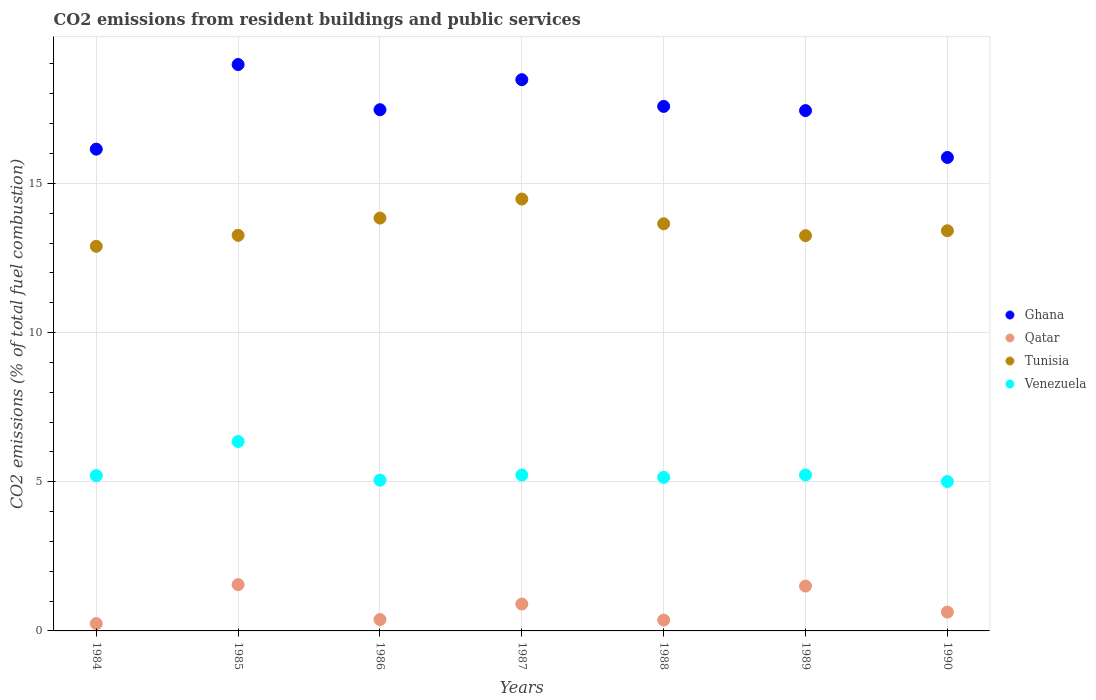How many different coloured dotlines are there?
Your response must be concise. 4. What is the total CO2 emitted in Tunisia in 1987?
Give a very brief answer. 14.47. Across all years, what is the maximum total CO2 emitted in Tunisia?
Your answer should be compact. 14.47. Across all years, what is the minimum total CO2 emitted in Ghana?
Your answer should be compact. 15.87. What is the total total CO2 emitted in Venezuela in the graph?
Your response must be concise. 37.21. What is the difference between the total CO2 emitted in Ghana in 1987 and that in 1989?
Give a very brief answer. 1.04. What is the difference between the total CO2 emitted in Qatar in 1985 and the total CO2 emitted in Venezuela in 1988?
Make the answer very short. -3.6. What is the average total CO2 emitted in Tunisia per year?
Offer a terse response. 13.54. In the year 1987, what is the difference between the total CO2 emitted in Qatar and total CO2 emitted in Tunisia?
Provide a succinct answer. -13.57. In how many years, is the total CO2 emitted in Qatar greater than 5?
Give a very brief answer. 0. What is the ratio of the total CO2 emitted in Venezuela in 1985 to that in 1990?
Offer a terse response. 1.27. Is the total CO2 emitted in Venezuela in 1984 less than that in 1990?
Offer a terse response. No. What is the difference between the highest and the second highest total CO2 emitted in Tunisia?
Your response must be concise. 0.64. What is the difference between the highest and the lowest total CO2 emitted in Ghana?
Provide a succinct answer. 3.11. Is the sum of the total CO2 emitted in Tunisia in 1988 and 1989 greater than the maximum total CO2 emitted in Venezuela across all years?
Your answer should be compact. Yes. Is it the case that in every year, the sum of the total CO2 emitted in Qatar and total CO2 emitted in Venezuela  is greater than the sum of total CO2 emitted in Tunisia and total CO2 emitted in Ghana?
Make the answer very short. No. Is it the case that in every year, the sum of the total CO2 emitted in Ghana and total CO2 emitted in Qatar  is greater than the total CO2 emitted in Venezuela?
Your response must be concise. Yes. Does the total CO2 emitted in Tunisia monotonically increase over the years?
Your answer should be compact. No. Is the total CO2 emitted in Tunisia strictly less than the total CO2 emitted in Venezuela over the years?
Ensure brevity in your answer.  No. Are the values on the major ticks of Y-axis written in scientific E-notation?
Your answer should be compact. No. Where does the legend appear in the graph?
Keep it short and to the point. Center right. How are the legend labels stacked?
Ensure brevity in your answer.  Vertical. What is the title of the graph?
Make the answer very short. CO2 emissions from resident buildings and public services. What is the label or title of the Y-axis?
Offer a terse response. CO2 emissions (% of total fuel combustion). What is the CO2 emissions (% of total fuel combustion) in Ghana in 1984?
Provide a succinct answer. 16.15. What is the CO2 emissions (% of total fuel combustion) of Qatar in 1984?
Give a very brief answer. 0.25. What is the CO2 emissions (% of total fuel combustion) of Tunisia in 1984?
Keep it short and to the point. 12.89. What is the CO2 emissions (% of total fuel combustion) in Venezuela in 1984?
Offer a terse response. 5.21. What is the CO2 emissions (% of total fuel combustion) of Ghana in 1985?
Your answer should be compact. 18.98. What is the CO2 emissions (% of total fuel combustion) in Qatar in 1985?
Your response must be concise. 1.55. What is the CO2 emissions (% of total fuel combustion) in Tunisia in 1985?
Offer a terse response. 13.26. What is the CO2 emissions (% of total fuel combustion) of Venezuela in 1985?
Offer a very short reply. 6.35. What is the CO2 emissions (% of total fuel combustion) of Ghana in 1986?
Your answer should be very brief. 17.47. What is the CO2 emissions (% of total fuel combustion) in Qatar in 1986?
Offer a very short reply. 0.38. What is the CO2 emissions (% of total fuel combustion) of Tunisia in 1986?
Provide a short and direct response. 13.84. What is the CO2 emissions (% of total fuel combustion) in Venezuela in 1986?
Offer a terse response. 5.05. What is the CO2 emissions (% of total fuel combustion) in Ghana in 1987?
Ensure brevity in your answer.  18.47. What is the CO2 emissions (% of total fuel combustion) in Qatar in 1987?
Make the answer very short. 0.9. What is the CO2 emissions (% of total fuel combustion) of Tunisia in 1987?
Your response must be concise. 14.47. What is the CO2 emissions (% of total fuel combustion) in Venezuela in 1987?
Offer a very short reply. 5.22. What is the CO2 emissions (% of total fuel combustion) of Ghana in 1988?
Offer a very short reply. 17.58. What is the CO2 emissions (% of total fuel combustion) in Qatar in 1988?
Provide a short and direct response. 0.36. What is the CO2 emissions (% of total fuel combustion) of Tunisia in 1988?
Ensure brevity in your answer.  13.64. What is the CO2 emissions (% of total fuel combustion) in Venezuela in 1988?
Make the answer very short. 5.15. What is the CO2 emissions (% of total fuel combustion) of Ghana in 1989?
Your response must be concise. 17.44. What is the CO2 emissions (% of total fuel combustion) of Qatar in 1989?
Your response must be concise. 1.5. What is the CO2 emissions (% of total fuel combustion) of Tunisia in 1989?
Offer a terse response. 13.25. What is the CO2 emissions (% of total fuel combustion) of Venezuela in 1989?
Ensure brevity in your answer.  5.23. What is the CO2 emissions (% of total fuel combustion) of Ghana in 1990?
Provide a short and direct response. 15.87. What is the CO2 emissions (% of total fuel combustion) of Qatar in 1990?
Give a very brief answer. 0.63. What is the CO2 emissions (% of total fuel combustion) of Tunisia in 1990?
Your answer should be compact. 13.41. What is the CO2 emissions (% of total fuel combustion) in Venezuela in 1990?
Ensure brevity in your answer.  5.01. Across all years, what is the maximum CO2 emissions (% of total fuel combustion) of Ghana?
Make the answer very short. 18.98. Across all years, what is the maximum CO2 emissions (% of total fuel combustion) in Qatar?
Offer a terse response. 1.55. Across all years, what is the maximum CO2 emissions (% of total fuel combustion) in Tunisia?
Give a very brief answer. 14.47. Across all years, what is the maximum CO2 emissions (% of total fuel combustion) in Venezuela?
Offer a very short reply. 6.35. Across all years, what is the minimum CO2 emissions (% of total fuel combustion) of Ghana?
Ensure brevity in your answer.  15.87. Across all years, what is the minimum CO2 emissions (% of total fuel combustion) of Qatar?
Give a very brief answer. 0.25. Across all years, what is the minimum CO2 emissions (% of total fuel combustion) of Tunisia?
Offer a very short reply. 12.89. Across all years, what is the minimum CO2 emissions (% of total fuel combustion) in Venezuela?
Give a very brief answer. 5.01. What is the total CO2 emissions (% of total fuel combustion) of Ghana in the graph?
Keep it short and to the point. 121.95. What is the total CO2 emissions (% of total fuel combustion) in Qatar in the graph?
Your answer should be very brief. 5.57. What is the total CO2 emissions (% of total fuel combustion) of Tunisia in the graph?
Keep it short and to the point. 94.76. What is the total CO2 emissions (% of total fuel combustion) of Venezuela in the graph?
Your answer should be compact. 37.21. What is the difference between the CO2 emissions (% of total fuel combustion) of Ghana in 1984 and that in 1985?
Offer a terse response. -2.84. What is the difference between the CO2 emissions (% of total fuel combustion) in Qatar in 1984 and that in 1985?
Keep it short and to the point. -1.3. What is the difference between the CO2 emissions (% of total fuel combustion) of Tunisia in 1984 and that in 1985?
Offer a very short reply. -0.37. What is the difference between the CO2 emissions (% of total fuel combustion) in Venezuela in 1984 and that in 1985?
Provide a succinct answer. -1.14. What is the difference between the CO2 emissions (% of total fuel combustion) in Ghana in 1984 and that in 1986?
Ensure brevity in your answer.  -1.32. What is the difference between the CO2 emissions (% of total fuel combustion) in Qatar in 1984 and that in 1986?
Provide a succinct answer. -0.13. What is the difference between the CO2 emissions (% of total fuel combustion) in Tunisia in 1984 and that in 1986?
Provide a short and direct response. -0.95. What is the difference between the CO2 emissions (% of total fuel combustion) in Venezuela in 1984 and that in 1986?
Provide a short and direct response. 0.15. What is the difference between the CO2 emissions (% of total fuel combustion) in Ghana in 1984 and that in 1987?
Keep it short and to the point. -2.33. What is the difference between the CO2 emissions (% of total fuel combustion) of Qatar in 1984 and that in 1987?
Your response must be concise. -0.65. What is the difference between the CO2 emissions (% of total fuel combustion) of Tunisia in 1984 and that in 1987?
Your response must be concise. -1.58. What is the difference between the CO2 emissions (% of total fuel combustion) in Venezuela in 1984 and that in 1987?
Give a very brief answer. -0.02. What is the difference between the CO2 emissions (% of total fuel combustion) of Ghana in 1984 and that in 1988?
Offer a terse response. -1.43. What is the difference between the CO2 emissions (% of total fuel combustion) in Qatar in 1984 and that in 1988?
Make the answer very short. -0.12. What is the difference between the CO2 emissions (% of total fuel combustion) in Tunisia in 1984 and that in 1988?
Offer a very short reply. -0.76. What is the difference between the CO2 emissions (% of total fuel combustion) in Venezuela in 1984 and that in 1988?
Provide a short and direct response. 0.06. What is the difference between the CO2 emissions (% of total fuel combustion) of Ghana in 1984 and that in 1989?
Ensure brevity in your answer.  -1.29. What is the difference between the CO2 emissions (% of total fuel combustion) in Qatar in 1984 and that in 1989?
Your answer should be compact. -1.26. What is the difference between the CO2 emissions (% of total fuel combustion) of Tunisia in 1984 and that in 1989?
Keep it short and to the point. -0.36. What is the difference between the CO2 emissions (% of total fuel combustion) of Venezuela in 1984 and that in 1989?
Your response must be concise. -0.02. What is the difference between the CO2 emissions (% of total fuel combustion) in Ghana in 1984 and that in 1990?
Ensure brevity in your answer.  0.28. What is the difference between the CO2 emissions (% of total fuel combustion) in Qatar in 1984 and that in 1990?
Your answer should be very brief. -0.38. What is the difference between the CO2 emissions (% of total fuel combustion) of Tunisia in 1984 and that in 1990?
Your answer should be very brief. -0.52. What is the difference between the CO2 emissions (% of total fuel combustion) of Venezuela in 1984 and that in 1990?
Your answer should be compact. 0.2. What is the difference between the CO2 emissions (% of total fuel combustion) of Ghana in 1985 and that in 1986?
Ensure brevity in your answer.  1.51. What is the difference between the CO2 emissions (% of total fuel combustion) of Qatar in 1985 and that in 1986?
Provide a succinct answer. 1.17. What is the difference between the CO2 emissions (% of total fuel combustion) of Tunisia in 1985 and that in 1986?
Give a very brief answer. -0.58. What is the difference between the CO2 emissions (% of total fuel combustion) of Venezuela in 1985 and that in 1986?
Give a very brief answer. 1.3. What is the difference between the CO2 emissions (% of total fuel combustion) of Ghana in 1985 and that in 1987?
Your response must be concise. 0.51. What is the difference between the CO2 emissions (% of total fuel combustion) of Qatar in 1985 and that in 1987?
Keep it short and to the point. 0.65. What is the difference between the CO2 emissions (% of total fuel combustion) of Tunisia in 1985 and that in 1987?
Give a very brief answer. -1.22. What is the difference between the CO2 emissions (% of total fuel combustion) in Venezuela in 1985 and that in 1987?
Give a very brief answer. 1.12. What is the difference between the CO2 emissions (% of total fuel combustion) of Ghana in 1985 and that in 1988?
Ensure brevity in your answer.  1.4. What is the difference between the CO2 emissions (% of total fuel combustion) of Qatar in 1985 and that in 1988?
Provide a short and direct response. 1.19. What is the difference between the CO2 emissions (% of total fuel combustion) of Tunisia in 1985 and that in 1988?
Your response must be concise. -0.39. What is the difference between the CO2 emissions (% of total fuel combustion) in Venezuela in 1985 and that in 1988?
Provide a succinct answer. 1.2. What is the difference between the CO2 emissions (% of total fuel combustion) of Ghana in 1985 and that in 1989?
Your answer should be compact. 1.54. What is the difference between the CO2 emissions (% of total fuel combustion) of Qatar in 1985 and that in 1989?
Offer a terse response. 0.05. What is the difference between the CO2 emissions (% of total fuel combustion) of Tunisia in 1985 and that in 1989?
Offer a very short reply. 0.01. What is the difference between the CO2 emissions (% of total fuel combustion) in Venezuela in 1985 and that in 1989?
Your answer should be compact. 1.12. What is the difference between the CO2 emissions (% of total fuel combustion) in Ghana in 1985 and that in 1990?
Ensure brevity in your answer.  3.11. What is the difference between the CO2 emissions (% of total fuel combustion) in Qatar in 1985 and that in 1990?
Provide a succinct answer. 0.92. What is the difference between the CO2 emissions (% of total fuel combustion) of Tunisia in 1985 and that in 1990?
Offer a terse response. -0.15. What is the difference between the CO2 emissions (% of total fuel combustion) of Venezuela in 1985 and that in 1990?
Provide a succinct answer. 1.34. What is the difference between the CO2 emissions (% of total fuel combustion) in Ghana in 1986 and that in 1987?
Keep it short and to the point. -1.01. What is the difference between the CO2 emissions (% of total fuel combustion) of Qatar in 1986 and that in 1987?
Your response must be concise. -0.52. What is the difference between the CO2 emissions (% of total fuel combustion) of Tunisia in 1986 and that in 1987?
Provide a succinct answer. -0.64. What is the difference between the CO2 emissions (% of total fuel combustion) in Venezuela in 1986 and that in 1987?
Provide a succinct answer. -0.17. What is the difference between the CO2 emissions (% of total fuel combustion) of Ghana in 1986 and that in 1988?
Your response must be concise. -0.11. What is the difference between the CO2 emissions (% of total fuel combustion) in Qatar in 1986 and that in 1988?
Ensure brevity in your answer.  0.02. What is the difference between the CO2 emissions (% of total fuel combustion) in Tunisia in 1986 and that in 1988?
Offer a terse response. 0.19. What is the difference between the CO2 emissions (% of total fuel combustion) in Venezuela in 1986 and that in 1988?
Your answer should be compact. -0.1. What is the difference between the CO2 emissions (% of total fuel combustion) in Ghana in 1986 and that in 1989?
Offer a very short reply. 0.03. What is the difference between the CO2 emissions (% of total fuel combustion) in Qatar in 1986 and that in 1989?
Keep it short and to the point. -1.12. What is the difference between the CO2 emissions (% of total fuel combustion) in Tunisia in 1986 and that in 1989?
Your answer should be compact. 0.59. What is the difference between the CO2 emissions (% of total fuel combustion) of Venezuela in 1986 and that in 1989?
Provide a succinct answer. -0.18. What is the difference between the CO2 emissions (% of total fuel combustion) in Ghana in 1986 and that in 1990?
Offer a terse response. 1.6. What is the difference between the CO2 emissions (% of total fuel combustion) in Qatar in 1986 and that in 1990?
Your response must be concise. -0.25. What is the difference between the CO2 emissions (% of total fuel combustion) in Tunisia in 1986 and that in 1990?
Provide a succinct answer. 0.42. What is the difference between the CO2 emissions (% of total fuel combustion) of Venezuela in 1986 and that in 1990?
Make the answer very short. 0.05. What is the difference between the CO2 emissions (% of total fuel combustion) of Ghana in 1987 and that in 1988?
Give a very brief answer. 0.9. What is the difference between the CO2 emissions (% of total fuel combustion) in Qatar in 1987 and that in 1988?
Provide a short and direct response. 0.54. What is the difference between the CO2 emissions (% of total fuel combustion) in Tunisia in 1987 and that in 1988?
Provide a short and direct response. 0.83. What is the difference between the CO2 emissions (% of total fuel combustion) of Venezuela in 1987 and that in 1988?
Keep it short and to the point. 0.08. What is the difference between the CO2 emissions (% of total fuel combustion) in Ghana in 1987 and that in 1989?
Ensure brevity in your answer.  1.04. What is the difference between the CO2 emissions (% of total fuel combustion) of Qatar in 1987 and that in 1989?
Your response must be concise. -0.6. What is the difference between the CO2 emissions (% of total fuel combustion) of Tunisia in 1987 and that in 1989?
Your answer should be very brief. 1.23. What is the difference between the CO2 emissions (% of total fuel combustion) of Venezuela in 1987 and that in 1989?
Provide a succinct answer. -0. What is the difference between the CO2 emissions (% of total fuel combustion) of Ghana in 1987 and that in 1990?
Your answer should be very brief. 2.61. What is the difference between the CO2 emissions (% of total fuel combustion) of Qatar in 1987 and that in 1990?
Provide a short and direct response. 0.27. What is the difference between the CO2 emissions (% of total fuel combustion) in Tunisia in 1987 and that in 1990?
Offer a very short reply. 1.06. What is the difference between the CO2 emissions (% of total fuel combustion) in Venezuela in 1987 and that in 1990?
Your answer should be very brief. 0.22. What is the difference between the CO2 emissions (% of total fuel combustion) of Ghana in 1988 and that in 1989?
Give a very brief answer. 0.14. What is the difference between the CO2 emissions (% of total fuel combustion) of Qatar in 1988 and that in 1989?
Your response must be concise. -1.14. What is the difference between the CO2 emissions (% of total fuel combustion) of Tunisia in 1988 and that in 1989?
Offer a very short reply. 0.4. What is the difference between the CO2 emissions (% of total fuel combustion) of Venezuela in 1988 and that in 1989?
Provide a succinct answer. -0.08. What is the difference between the CO2 emissions (% of total fuel combustion) of Ghana in 1988 and that in 1990?
Provide a short and direct response. 1.71. What is the difference between the CO2 emissions (% of total fuel combustion) in Qatar in 1988 and that in 1990?
Your answer should be compact. -0.27. What is the difference between the CO2 emissions (% of total fuel combustion) of Tunisia in 1988 and that in 1990?
Your answer should be compact. 0.23. What is the difference between the CO2 emissions (% of total fuel combustion) of Venezuela in 1988 and that in 1990?
Offer a terse response. 0.14. What is the difference between the CO2 emissions (% of total fuel combustion) of Ghana in 1989 and that in 1990?
Ensure brevity in your answer.  1.57. What is the difference between the CO2 emissions (% of total fuel combustion) in Qatar in 1989 and that in 1990?
Your response must be concise. 0.87. What is the difference between the CO2 emissions (% of total fuel combustion) in Tunisia in 1989 and that in 1990?
Offer a terse response. -0.16. What is the difference between the CO2 emissions (% of total fuel combustion) of Venezuela in 1989 and that in 1990?
Offer a terse response. 0.22. What is the difference between the CO2 emissions (% of total fuel combustion) in Ghana in 1984 and the CO2 emissions (% of total fuel combustion) in Qatar in 1985?
Ensure brevity in your answer.  14.59. What is the difference between the CO2 emissions (% of total fuel combustion) of Ghana in 1984 and the CO2 emissions (% of total fuel combustion) of Tunisia in 1985?
Your answer should be compact. 2.89. What is the difference between the CO2 emissions (% of total fuel combustion) of Ghana in 1984 and the CO2 emissions (% of total fuel combustion) of Venezuela in 1985?
Keep it short and to the point. 9.8. What is the difference between the CO2 emissions (% of total fuel combustion) of Qatar in 1984 and the CO2 emissions (% of total fuel combustion) of Tunisia in 1985?
Provide a short and direct response. -13.01. What is the difference between the CO2 emissions (% of total fuel combustion) of Qatar in 1984 and the CO2 emissions (% of total fuel combustion) of Venezuela in 1985?
Ensure brevity in your answer.  -6.1. What is the difference between the CO2 emissions (% of total fuel combustion) of Tunisia in 1984 and the CO2 emissions (% of total fuel combustion) of Venezuela in 1985?
Offer a terse response. 6.54. What is the difference between the CO2 emissions (% of total fuel combustion) of Ghana in 1984 and the CO2 emissions (% of total fuel combustion) of Qatar in 1986?
Offer a terse response. 15.77. What is the difference between the CO2 emissions (% of total fuel combustion) in Ghana in 1984 and the CO2 emissions (% of total fuel combustion) in Tunisia in 1986?
Your answer should be compact. 2.31. What is the difference between the CO2 emissions (% of total fuel combustion) of Ghana in 1984 and the CO2 emissions (% of total fuel combustion) of Venezuela in 1986?
Your response must be concise. 11.09. What is the difference between the CO2 emissions (% of total fuel combustion) of Qatar in 1984 and the CO2 emissions (% of total fuel combustion) of Tunisia in 1986?
Offer a terse response. -13.59. What is the difference between the CO2 emissions (% of total fuel combustion) of Qatar in 1984 and the CO2 emissions (% of total fuel combustion) of Venezuela in 1986?
Your response must be concise. -4.8. What is the difference between the CO2 emissions (% of total fuel combustion) of Tunisia in 1984 and the CO2 emissions (% of total fuel combustion) of Venezuela in 1986?
Offer a very short reply. 7.84. What is the difference between the CO2 emissions (% of total fuel combustion) in Ghana in 1984 and the CO2 emissions (% of total fuel combustion) in Qatar in 1987?
Your answer should be compact. 15.25. What is the difference between the CO2 emissions (% of total fuel combustion) of Ghana in 1984 and the CO2 emissions (% of total fuel combustion) of Tunisia in 1987?
Keep it short and to the point. 1.67. What is the difference between the CO2 emissions (% of total fuel combustion) in Ghana in 1984 and the CO2 emissions (% of total fuel combustion) in Venezuela in 1987?
Provide a short and direct response. 10.92. What is the difference between the CO2 emissions (% of total fuel combustion) in Qatar in 1984 and the CO2 emissions (% of total fuel combustion) in Tunisia in 1987?
Provide a succinct answer. -14.23. What is the difference between the CO2 emissions (% of total fuel combustion) in Qatar in 1984 and the CO2 emissions (% of total fuel combustion) in Venezuela in 1987?
Provide a succinct answer. -4.98. What is the difference between the CO2 emissions (% of total fuel combustion) of Tunisia in 1984 and the CO2 emissions (% of total fuel combustion) of Venezuela in 1987?
Ensure brevity in your answer.  7.67. What is the difference between the CO2 emissions (% of total fuel combustion) of Ghana in 1984 and the CO2 emissions (% of total fuel combustion) of Qatar in 1988?
Make the answer very short. 15.78. What is the difference between the CO2 emissions (% of total fuel combustion) in Ghana in 1984 and the CO2 emissions (% of total fuel combustion) in Tunisia in 1988?
Your answer should be very brief. 2.5. What is the difference between the CO2 emissions (% of total fuel combustion) of Ghana in 1984 and the CO2 emissions (% of total fuel combustion) of Venezuela in 1988?
Give a very brief answer. 11. What is the difference between the CO2 emissions (% of total fuel combustion) in Qatar in 1984 and the CO2 emissions (% of total fuel combustion) in Tunisia in 1988?
Your answer should be very brief. -13.4. What is the difference between the CO2 emissions (% of total fuel combustion) of Qatar in 1984 and the CO2 emissions (% of total fuel combustion) of Venezuela in 1988?
Your response must be concise. -4.9. What is the difference between the CO2 emissions (% of total fuel combustion) in Tunisia in 1984 and the CO2 emissions (% of total fuel combustion) in Venezuela in 1988?
Keep it short and to the point. 7.74. What is the difference between the CO2 emissions (% of total fuel combustion) of Ghana in 1984 and the CO2 emissions (% of total fuel combustion) of Qatar in 1989?
Offer a very short reply. 14.64. What is the difference between the CO2 emissions (% of total fuel combustion) of Ghana in 1984 and the CO2 emissions (% of total fuel combustion) of Tunisia in 1989?
Provide a short and direct response. 2.9. What is the difference between the CO2 emissions (% of total fuel combustion) of Ghana in 1984 and the CO2 emissions (% of total fuel combustion) of Venezuela in 1989?
Offer a very short reply. 10.92. What is the difference between the CO2 emissions (% of total fuel combustion) in Qatar in 1984 and the CO2 emissions (% of total fuel combustion) in Tunisia in 1989?
Offer a terse response. -13. What is the difference between the CO2 emissions (% of total fuel combustion) in Qatar in 1984 and the CO2 emissions (% of total fuel combustion) in Venezuela in 1989?
Provide a succinct answer. -4.98. What is the difference between the CO2 emissions (% of total fuel combustion) in Tunisia in 1984 and the CO2 emissions (% of total fuel combustion) in Venezuela in 1989?
Provide a succinct answer. 7.66. What is the difference between the CO2 emissions (% of total fuel combustion) in Ghana in 1984 and the CO2 emissions (% of total fuel combustion) in Qatar in 1990?
Your response must be concise. 15.52. What is the difference between the CO2 emissions (% of total fuel combustion) of Ghana in 1984 and the CO2 emissions (% of total fuel combustion) of Tunisia in 1990?
Your response must be concise. 2.74. What is the difference between the CO2 emissions (% of total fuel combustion) in Ghana in 1984 and the CO2 emissions (% of total fuel combustion) in Venezuela in 1990?
Keep it short and to the point. 11.14. What is the difference between the CO2 emissions (% of total fuel combustion) of Qatar in 1984 and the CO2 emissions (% of total fuel combustion) of Tunisia in 1990?
Ensure brevity in your answer.  -13.16. What is the difference between the CO2 emissions (% of total fuel combustion) of Qatar in 1984 and the CO2 emissions (% of total fuel combustion) of Venezuela in 1990?
Your response must be concise. -4.76. What is the difference between the CO2 emissions (% of total fuel combustion) in Tunisia in 1984 and the CO2 emissions (% of total fuel combustion) in Venezuela in 1990?
Keep it short and to the point. 7.88. What is the difference between the CO2 emissions (% of total fuel combustion) of Ghana in 1985 and the CO2 emissions (% of total fuel combustion) of Qatar in 1986?
Provide a succinct answer. 18.6. What is the difference between the CO2 emissions (% of total fuel combustion) in Ghana in 1985 and the CO2 emissions (% of total fuel combustion) in Tunisia in 1986?
Keep it short and to the point. 5.15. What is the difference between the CO2 emissions (% of total fuel combustion) of Ghana in 1985 and the CO2 emissions (% of total fuel combustion) of Venezuela in 1986?
Your answer should be very brief. 13.93. What is the difference between the CO2 emissions (% of total fuel combustion) in Qatar in 1985 and the CO2 emissions (% of total fuel combustion) in Tunisia in 1986?
Make the answer very short. -12.28. What is the difference between the CO2 emissions (% of total fuel combustion) of Qatar in 1985 and the CO2 emissions (% of total fuel combustion) of Venezuela in 1986?
Ensure brevity in your answer.  -3.5. What is the difference between the CO2 emissions (% of total fuel combustion) of Tunisia in 1985 and the CO2 emissions (% of total fuel combustion) of Venezuela in 1986?
Your answer should be very brief. 8.21. What is the difference between the CO2 emissions (% of total fuel combustion) in Ghana in 1985 and the CO2 emissions (% of total fuel combustion) in Qatar in 1987?
Provide a succinct answer. 18.08. What is the difference between the CO2 emissions (% of total fuel combustion) of Ghana in 1985 and the CO2 emissions (% of total fuel combustion) of Tunisia in 1987?
Your answer should be very brief. 4.51. What is the difference between the CO2 emissions (% of total fuel combustion) of Ghana in 1985 and the CO2 emissions (% of total fuel combustion) of Venezuela in 1987?
Make the answer very short. 13.76. What is the difference between the CO2 emissions (% of total fuel combustion) of Qatar in 1985 and the CO2 emissions (% of total fuel combustion) of Tunisia in 1987?
Your answer should be very brief. -12.92. What is the difference between the CO2 emissions (% of total fuel combustion) in Qatar in 1985 and the CO2 emissions (% of total fuel combustion) in Venezuela in 1987?
Offer a terse response. -3.67. What is the difference between the CO2 emissions (% of total fuel combustion) of Tunisia in 1985 and the CO2 emissions (% of total fuel combustion) of Venezuela in 1987?
Offer a terse response. 8.03. What is the difference between the CO2 emissions (% of total fuel combustion) in Ghana in 1985 and the CO2 emissions (% of total fuel combustion) in Qatar in 1988?
Make the answer very short. 18.62. What is the difference between the CO2 emissions (% of total fuel combustion) in Ghana in 1985 and the CO2 emissions (% of total fuel combustion) in Tunisia in 1988?
Ensure brevity in your answer.  5.34. What is the difference between the CO2 emissions (% of total fuel combustion) in Ghana in 1985 and the CO2 emissions (% of total fuel combustion) in Venezuela in 1988?
Your response must be concise. 13.83. What is the difference between the CO2 emissions (% of total fuel combustion) in Qatar in 1985 and the CO2 emissions (% of total fuel combustion) in Tunisia in 1988?
Give a very brief answer. -12.09. What is the difference between the CO2 emissions (% of total fuel combustion) in Qatar in 1985 and the CO2 emissions (% of total fuel combustion) in Venezuela in 1988?
Provide a succinct answer. -3.6. What is the difference between the CO2 emissions (% of total fuel combustion) of Tunisia in 1985 and the CO2 emissions (% of total fuel combustion) of Venezuela in 1988?
Your response must be concise. 8.11. What is the difference between the CO2 emissions (% of total fuel combustion) of Ghana in 1985 and the CO2 emissions (% of total fuel combustion) of Qatar in 1989?
Offer a terse response. 17.48. What is the difference between the CO2 emissions (% of total fuel combustion) of Ghana in 1985 and the CO2 emissions (% of total fuel combustion) of Tunisia in 1989?
Your response must be concise. 5.73. What is the difference between the CO2 emissions (% of total fuel combustion) in Ghana in 1985 and the CO2 emissions (% of total fuel combustion) in Venezuela in 1989?
Offer a terse response. 13.75. What is the difference between the CO2 emissions (% of total fuel combustion) in Qatar in 1985 and the CO2 emissions (% of total fuel combustion) in Tunisia in 1989?
Offer a very short reply. -11.7. What is the difference between the CO2 emissions (% of total fuel combustion) in Qatar in 1985 and the CO2 emissions (% of total fuel combustion) in Venezuela in 1989?
Provide a short and direct response. -3.68. What is the difference between the CO2 emissions (% of total fuel combustion) of Tunisia in 1985 and the CO2 emissions (% of total fuel combustion) of Venezuela in 1989?
Keep it short and to the point. 8.03. What is the difference between the CO2 emissions (% of total fuel combustion) of Ghana in 1985 and the CO2 emissions (% of total fuel combustion) of Qatar in 1990?
Ensure brevity in your answer.  18.35. What is the difference between the CO2 emissions (% of total fuel combustion) in Ghana in 1985 and the CO2 emissions (% of total fuel combustion) in Tunisia in 1990?
Ensure brevity in your answer.  5.57. What is the difference between the CO2 emissions (% of total fuel combustion) of Ghana in 1985 and the CO2 emissions (% of total fuel combustion) of Venezuela in 1990?
Provide a short and direct response. 13.98. What is the difference between the CO2 emissions (% of total fuel combustion) of Qatar in 1985 and the CO2 emissions (% of total fuel combustion) of Tunisia in 1990?
Keep it short and to the point. -11.86. What is the difference between the CO2 emissions (% of total fuel combustion) of Qatar in 1985 and the CO2 emissions (% of total fuel combustion) of Venezuela in 1990?
Your answer should be compact. -3.45. What is the difference between the CO2 emissions (% of total fuel combustion) in Tunisia in 1985 and the CO2 emissions (% of total fuel combustion) in Venezuela in 1990?
Your answer should be compact. 8.25. What is the difference between the CO2 emissions (% of total fuel combustion) in Ghana in 1986 and the CO2 emissions (% of total fuel combustion) in Qatar in 1987?
Offer a terse response. 16.57. What is the difference between the CO2 emissions (% of total fuel combustion) in Ghana in 1986 and the CO2 emissions (% of total fuel combustion) in Tunisia in 1987?
Your response must be concise. 2.99. What is the difference between the CO2 emissions (% of total fuel combustion) of Ghana in 1986 and the CO2 emissions (% of total fuel combustion) of Venezuela in 1987?
Your answer should be compact. 12.24. What is the difference between the CO2 emissions (% of total fuel combustion) of Qatar in 1986 and the CO2 emissions (% of total fuel combustion) of Tunisia in 1987?
Make the answer very short. -14.09. What is the difference between the CO2 emissions (% of total fuel combustion) of Qatar in 1986 and the CO2 emissions (% of total fuel combustion) of Venezuela in 1987?
Offer a terse response. -4.84. What is the difference between the CO2 emissions (% of total fuel combustion) of Tunisia in 1986 and the CO2 emissions (% of total fuel combustion) of Venezuela in 1987?
Keep it short and to the point. 8.61. What is the difference between the CO2 emissions (% of total fuel combustion) in Ghana in 1986 and the CO2 emissions (% of total fuel combustion) in Qatar in 1988?
Offer a very short reply. 17.1. What is the difference between the CO2 emissions (% of total fuel combustion) in Ghana in 1986 and the CO2 emissions (% of total fuel combustion) in Tunisia in 1988?
Provide a succinct answer. 3.82. What is the difference between the CO2 emissions (% of total fuel combustion) of Ghana in 1986 and the CO2 emissions (% of total fuel combustion) of Venezuela in 1988?
Offer a terse response. 12.32. What is the difference between the CO2 emissions (% of total fuel combustion) in Qatar in 1986 and the CO2 emissions (% of total fuel combustion) in Tunisia in 1988?
Keep it short and to the point. -13.26. What is the difference between the CO2 emissions (% of total fuel combustion) in Qatar in 1986 and the CO2 emissions (% of total fuel combustion) in Venezuela in 1988?
Provide a short and direct response. -4.77. What is the difference between the CO2 emissions (% of total fuel combustion) in Tunisia in 1986 and the CO2 emissions (% of total fuel combustion) in Venezuela in 1988?
Make the answer very short. 8.69. What is the difference between the CO2 emissions (% of total fuel combustion) in Ghana in 1986 and the CO2 emissions (% of total fuel combustion) in Qatar in 1989?
Your answer should be very brief. 15.96. What is the difference between the CO2 emissions (% of total fuel combustion) in Ghana in 1986 and the CO2 emissions (% of total fuel combustion) in Tunisia in 1989?
Keep it short and to the point. 4.22. What is the difference between the CO2 emissions (% of total fuel combustion) in Ghana in 1986 and the CO2 emissions (% of total fuel combustion) in Venezuela in 1989?
Provide a short and direct response. 12.24. What is the difference between the CO2 emissions (% of total fuel combustion) of Qatar in 1986 and the CO2 emissions (% of total fuel combustion) of Tunisia in 1989?
Offer a very short reply. -12.87. What is the difference between the CO2 emissions (% of total fuel combustion) in Qatar in 1986 and the CO2 emissions (% of total fuel combustion) in Venezuela in 1989?
Keep it short and to the point. -4.85. What is the difference between the CO2 emissions (% of total fuel combustion) of Tunisia in 1986 and the CO2 emissions (% of total fuel combustion) of Venezuela in 1989?
Ensure brevity in your answer.  8.61. What is the difference between the CO2 emissions (% of total fuel combustion) in Ghana in 1986 and the CO2 emissions (% of total fuel combustion) in Qatar in 1990?
Provide a short and direct response. 16.84. What is the difference between the CO2 emissions (% of total fuel combustion) of Ghana in 1986 and the CO2 emissions (% of total fuel combustion) of Tunisia in 1990?
Your response must be concise. 4.06. What is the difference between the CO2 emissions (% of total fuel combustion) of Ghana in 1986 and the CO2 emissions (% of total fuel combustion) of Venezuela in 1990?
Ensure brevity in your answer.  12.46. What is the difference between the CO2 emissions (% of total fuel combustion) of Qatar in 1986 and the CO2 emissions (% of total fuel combustion) of Tunisia in 1990?
Keep it short and to the point. -13.03. What is the difference between the CO2 emissions (% of total fuel combustion) in Qatar in 1986 and the CO2 emissions (% of total fuel combustion) in Venezuela in 1990?
Keep it short and to the point. -4.62. What is the difference between the CO2 emissions (% of total fuel combustion) of Tunisia in 1986 and the CO2 emissions (% of total fuel combustion) of Venezuela in 1990?
Keep it short and to the point. 8.83. What is the difference between the CO2 emissions (% of total fuel combustion) in Ghana in 1987 and the CO2 emissions (% of total fuel combustion) in Qatar in 1988?
Your answer should be compact. 18.11. What is the difference between the CO2 emissions (% of total fuel combustion) of Ghana in 1987 and the CO2 emissions (% of total fuel combustion) of Tunisia in 1988?
Keep it short and to the point. 4.83. What is the difference between the CO2 emissions (% of total fuel combustion) of Ghana in 1987 and the CO2 emissions (% of total fuel combustion) of Venezuela in 1988?
Offer a terse response. 13.33. What is the difference between the CO2 emissions (% of total fuel combustion) of Qatar in 1987 and the CO2 emissions (% of total fuel combustion) of Tunisia in 1988?
Your answer should be very brief. -12.75. What is the difference between the CO2 emissions (% of total fuel combustion) in Qatar in 1987 and the CO2 emissions (% of total fuel combustion) in Venezuela in 1988?
Your answer should be compact. -4.25. What is the difference between the CO2 emissions (% of total fuel combustion) in Tunisia in 1987 and the CO2 emissions (% of total fuel combustion) in Venezuela in 1988?
Keep it short and to the point. 9.33. What is the difference between the CO2 emissions (% of total fuel combustion) of Ghana in 1987 and the CO2 emissions (% of total fuel combustion) of Qatar in 1989?
Ensure brevity in your answer.  16.97. What is the difference between the CO2 emissions (% of total fuel combustion) in Ghana in 1987 and the CO2 emissions (% of total fuel combustion) in Tunisia in 1989?
Provide a short and direct response. 5.23. What is the difference between the CO2 emissions (% of total fuel combustion) of Ghana in 1987 and the CO2 emissions (% of total fuel combustion) of Venezuela in 1989?
Ensure brevity in your answer.  13.25. What is the difference between the CO2 emissions (% of total fuel combustion) of Qatar in 1987 and the CO2 emissions (% of total fuel combustion) of Tunisia in 1989?
Provide a succinct answer. -12.35. What is the difference between the CO2 emissions (% of total fuel combustion) in Qatar in 1987 and the CO2 emissions (% of total fuel combustion) in Venezuela in 1989?
Keep it short and to the point. -4.33. What is the difference between the CO2 emissions (% of total fuel combustion) in Tunisia in 1987 and the CO2 emissions (% of total fuel combustion) in Venezuela in 1989?
Provide a short and direct response. 9.25. What is the difference between the CO2 emissions (% of total fuel combustion) in Ghana in 1987 and the CO2 emissions (% of total fuel combustion) in Qatar in 1990?
Your response must be concise. 17.84. What is the difference between the CO2 emissions (% of total fuel combustion) of Ghana in 1987 and the CO2 emissions (% of total fuel combustion) of Tunisia in 1990?
Offer a terse response. 5.06. What is the difference between the CO2 emissions (% of total fuel combustion) of Ghana in 1987 and the CO2 emissions (% of total fuel combustion) of Venezuela in 1990?
Your answer should be very brief. 13.47. What is the difference between the CO2 emissions (% of total fuel combustion) of Qatar in 1987 and the CO2 emissions (% of total fuel combustion) of Tunisia in 1990?
Provide a short and direct response. -12.51. What is the difference between the CO2 emissions (% of total fuel combustion) of Qatar in 1987 and the CO2 emissions (% of total fuel combustion) of Venezuela in 1990?
Your answer should be compact. -4.11. What is the difference between the CO2 emissions (% of total fuel combustion) in Tunisia in 1987 and the CO2 emissions (% of total fuel combustion) in Venezuela in 1990?
Provide a succinct answer. 9.47. What is the difference between the CO2 emissions (% of total fuel combustion) in Ghana in 1988 and the CO2 emissions (% of total fuel combustion) in Qatar in 1989?
Your response must be concise. 16.08. What is the difference between the CO2 emissions (% of total fuel combustion) in Ghana in 1988 and the CO2 emissions (% of total fuel combustion) in Tunisia in 1989?
Your answer should be compact. 4.33. What is the difference between the CO2 emissions (% of total fuel combustion) of Ghana in 1988 and the CO2 emissions (% of total fuel combustion) of Venezuela in 1989?
Keep it short and to the point. 12.35. What is the difference between the CO2 emissions (% of total fuel combustion) in Qatar in 1988 and the CO2 emissions (% of total fuel combustion) in Tunisia in 1989?
Keep it short and to the point. -12.88. What is the difference between the CO2 emissions (% of total fuel combustion) in Qatar in 1988 and the CO2 emissions (% of total fuel combustion) in Venezuela in 1989?
Provide a succinct answer. -4.86. What is the difference between the CO2 emissions (% of total fuel combustion) in Tunisia in 1988 and the CO2 emissions (% of total fuel combustion) in Venezuela in 1989?
Give a very brief answer. 8.42. What is the difference between the CO2 emissions (% of total fuel combustion) of Ghana in 1988 and the CO2 emissions (% of total fuel combustion) of Qatar in 1990?
Make the answer very short. 16.95. What is the difference between the CO2 emissions (% of total fuel combustion) in Ghana in 1988 and the CO2 emissions (% of total fuel combustion) in Tunisia in 1990?
Keep it short and to the point. 4.17. What is the difference between the CO2 emissions (% of total fuel combustion) of Ghana in 1988 and the CO2 emissions (% of total fuel combustion) of Venezuela in 1990?
Keep it short and to the point. 12.57. What is the difference between the CO2 emissions (% of total fuel combustion) in Qatar in 1988 and the CO2 emissions (% of total fuel combustion) in Tunisia in 1990?
Provide a short and direct response. -13.05. What is the difference between the CO2 emissions (% of total fuel combustion) of Qatar in 1988 and the CO2 emissions (% of total fuel combustion) of Venezuela in 1990?
Offer a very short reply. -4.64. What is the difference between the CO2 emissions (% of total fuel combustion) of Tunisia in 1988 and the CO2 emissions (% of total fuel combustion) of Venezuela in 1990?
Your answer should be compact. 8.64. What is the difference between the CO2 emissions (% of total fuel combustion) of Ghana in 1989 and the CO2 emissions (% of total fuel combustion) of Qatar in 1990?
Make the answer very short. 16.81. What is the difference between the CO2 emissions (% of total fuel combustion) in Ghana in 1989 and the CO2 emissions (% of total fuel combustion) in Tunisia in 1990?
Offer a terse response. 4.03. What is the difference between the CO2 emissions (% of total fuel combustion) in Ghana in 1989 and the CO2 emissions (% of total fuel combustion) in Venezuela in 1990?
Make the answer very short. 12.43. What is the difference between the CO2 emissions (% of total fuel combustion) in Qatar in 1989 and the CO2 emissions (% of total fuel combustion) in Tunisia in 1990?
Offer a very short reply. -11.91. What is the difference between the CO2 emissions (% of total fuel combustion) of Qatar in 1989 and the CO2 emissions (% of total fuel combustion) of Venezuela in 1990?
Ensure brevity in your answer.  -3.5. What is the difference between the CO2 emissions (% of total fuel combustion) of Tunisia in 1989 and the CO2 emissions (% of total fuel combustion) of Venezuela in 1990?
Ensure brevity in your answer.  8.24. What is the average CO2 emissions (% of total fuel combustion) of Ghana per year?
Your answer should be very brief. 17.42. What is the average CO2 emissions (% of total fuel combustion) in Qatar per year?
Your answer should be very brief. 0.8. What is the average CO2 emissions (% of total fuel combustion) in Tunisia per year?
Offer a terse response. 13.54. What is the average CO2 emissions (% of total fuel combustion) of Venezuela per year?
Keep it short and to the point. 5.32. In the year 1984, what is the difference between the CO2 emissions (% of total fuel combustion) in Ghana and CO2 emissions (% of total fuel combustion) in Qatar?
Make the answer very short. 15.9. In the year 1984, what is the difference between the CO2 emissions (% of total fuel combustion) of Ghana and CO2 emissions (% of total fuel combustion) of Tunisia?
Make the answer very short. 3.26. In the year 1984, what is the difference between the CO2 emissions (% of total fuel combustion) in Ghana and CO2 emissions (% of total fuel combustion) in Venezuela?
Provide a succinct answer. 10.94. In the year 1984, what is the difference between the CO2 emissions (% of total fuel combustion) of Qatar and CO2 emissions (% of total fuel combustion) of Tunisia?
Your response must be concise. -12.64. In the year 1984, what is the difference between the CO2 emissions (% of total fuel combustion) in Qatar and CO2 emissions (% of total fuel combustion) in Venezuela?
Your response must be concise. -4.96. In the year 1984, what is the difference between the CO2 emissions (% of total fuel combustion) of Tunisia and CO2 emissions (% of total fuel combustion) of Venezuela?
Your answer should be compact. 7.68. In the year 1985, what is the difference between the CO2 emissions (% of total fuel combustion) of Ghana and CO2 emissions (% of total fuel combustion) of Qatar?
Make the answer very short. 17.43. In the year 1985, what is the difference between the CO2 emissions (% of total fuel combustion) of Ghana and CO2 emissions (% of total fuel combustion) of Tunisia?
Your answer should be very brief. 5.72. In the year 1985, what is the difference between the CO2 emissions (% of total fuel combustion) in Ghana and CO2 emissions (% of total fuel combustion) in Venezuela?
Offer a terse response. 12.63. In the year 1985, what is the difference between the CO2 emissions (% of total fuel combustion) in Qatar and CO2 emissions (% of total fuel combustion) in Tunisia?
Provide a succinct answer. -11.71. In the year 1985, what is the difference between the CO2 emissions (% of total fuel combustion) in Qatar and CO2 emissions (% of total fuel combustion) in Venezuela?
Provide a short and direct response. -4.8. In the year 1985, what is the difference between the CO2 emissions (% of total fuel combustion) of Tunisia and CO2 emissions (% of total fuel combustion) of Venezuela?
Your response must be concise. 6.91. In the year 1986, what is the difference between the CO2 emissions (% of total fuel combustion) of Ghana and CO2 emissions (% of total fuel combustion) of Qatar?
Ensure brevity in your answer.  17.09. In the year 1986, what is the difference between the CO2 emissions (% of total fuel combustion) of Ghana and CO2 emissions (% of total fuel combustion) of Tunisia?
Provide a short and direct response. 3.63. In the year 1986, what is the difference between the CO2 emissions (% of total fuel combustion) in Ghana and CO2 emissions (% of total fuel combustion) in Venezuela?
Give a very brief answer. 12.42. In the year 1986, what is the difference between the CO2 emissions (% of total fuel combustion) of Qatar and CO2 emissions (% of total fuel combustion) of Tunisia?
Make the answer very short. -13.45. In the year 1986, what is the difference between the CO2 emissions (% of total fuel combustion) of Qatar and CO2 emissions (% of total fuel combustion) of Venezuela?
Offer a terse response. -4.67. In the year 1986, what is the difference between the CO2 emissions (% of total fuel combustion) of Tunisia and CO2 emissions (% of total fuel combustion) of Venezuela?
Your answer should be compact. 8.78. In the year 1987, what is the difference between the CO2 emissions (% of total fuel combustion) of Ghana and CO2 emissions (% of total fuel combustion) of Qatar?
Offer a very short reply. 17.57. In the year 1987, what is the difference between the CO2 emissions (% of total fuel combustion) in Ghana and CO2 emissions (% of total fuel combustion) in Tunisia?
Offer a very short reply. 4. In the year 1987, what is the difference between the CO2 emissions (% of total fuel combustion) in Ghana and CO2 emissions (% of total fuel combustion) in Venezuela?
Give a very brief answer. 13.25. In the year 1987, what is the difference between the CO2 emissions (% of total fuel combustion) of Qatar and CO2 emissions (% of total fuel combustion) of Tunisia?
Make the answer very short. -13.57. In the year 1987, what is the difference between the CO2 emissions (% of total fuel combustion) of Qatar and CO2 emissions (% of total fuel combustion) of Venezuela?
Make the answer very short. -4.32. In the year 1987, what is the difference between the CO2 emissions (% of total fuel combustion) of Tunisia and CO2 emissions (% of total fuel combustion) of Venezuela?
Your response must be concise. 9.25. In the year 1988, what is the difference between the CO2 emissions (% of total fuel combustion) of Ghana and CO2 emissions (% of total fuel combustion) of Qatar?
Provide a short and direct response. 17.22. In the year 1988, what is the difference between the CO2 emissions (% of total fuel combustion) of Ghana and CO2 emissions (% of total fuel combustion) of Tunisia?
Provide a succinct answer. 3.93. In the year 1988, what is the difference between the CO2 emissions (% of total fuel combustion) of Ghana and CO2 emissions (% of total fuel combustion) of Venezuela?
Provide a short and direct response. 12.43. In the year 1988, what is the difference between the CO2 emissions (% of total fuel combustion) of Qatar and CO2 emissions (% of total fuel combustion) of Tunisia?
Give a very brief answer. -13.28. In the year 1988, what is the difference between the CO2 emissions (% of total fuel combustion) in Qatar and CO2 emissions (% of total fuel combustion) in Venezuela?
Ensure brevity in your answer.  -4.78. In the year 1988, what is the difference between the CO2 emissions (% of total fuel combustion) in Tunisia and CO2 emissions (% of total fuel combustion) in Venezuela?
Ensure brevity in your answer.  8.5. In the year 1989, what is the difference between the CO2 emissions (% of total fuel combustion) of Ghana and CO2 emissions (% of total fuel combustion) of Qatar?
Keep it short and to the point. 15.94. In the year 1989, what is the difference between the CO2 emissions (% of total fuel combustion) in Ghana and CO2 emissions (% of total fuel combustion) in Tunisia?
Give a very brief answer. 4.19. In the year 1989, what is the difference between the CO2 emissions (% of total fuel combustion) in Ghana and CO2 emissions (% of total fuel combustion) in Venezuela?
Your answer should be very brief. 12.21. In the year 1989, what is the difference between the CO2 emissions (% of total fuel combustion) in Qatar and CO2 emissions (% of total fuel combustion) in Tunisia?
Provide a short and direct response. -11.74. In the year 1989, what is the difference between the CO2 emissions (% of total fuel combustion) in Qatar and CO2 emissions (% of total fuel combustion) in Venezuela?
Your response must be concise. -3.72. In the year 1989, what is the difference between the CO2 emissions (% of total fuel combustion) of Tunisia and CO2 emissions (% of total fuel combustion) of Venezuela?
Ensure brevity in your answer.  8.02. In the year 1990, what is the difference between the CO2 emissions (% of total fuel combustion) in Ghana and CO2 emissions (% of total fuel combustion) in Qatar?
Provide a succinct answer. 15.24. In the year 1990, what is the difference between the CO2 emissions (% of total fuel combustion) in Ghana and CO2 emissions (% of total fuel combustion) in Tunisia?
Provide a succinct answer. 2.46. In the year 1990, what is the difference between the CO2 emissions (% of total fuel combustion) in Ghana and CO2 emissions (% of total fuel combustion) in Venezuela?
Your answer should be very brief. 10.86. In the year 1990, what is the difference between the CO2 emissions (% of total fuel combustion) of Qatar and CO2 emissions (% of total fuel combustion) of Tunisia?
Ensure brevity in your answer.  -12.78. In the year 1990, what is the difference between the CO2 emissions (% of total fuel combustion) in Qatar and CO2 emissions (% of total fuel combustion) in Venezuela?
Give a very brief answer. -4.38. In the year 1990, what is the difference between the CO2 emissions (% of total fuel combustion) of Tunisia and CO2 emissions (% of total fuel combustion) of Venezuela?
Your answer should be compact. 8.41. What is the ratio of the CO2 emissions (% of total fuel combustion) of Ghana in 1984 to that in 1985?
Offer a very short reply. 0.85. What is the ratio of the CO2 emissions (% of total fuel combustion) of Qatar in 1984 to that in 1985?
Offer a terse response. 0.16. What is the ratio of the CO2 emissions (% of total fuel combustion) in Tunisia in 1984 to that in 1985?
Your answer should be very brief. 0.97. What is the ratio of the CO2 emissions (% of total fuel combustion) in Venezuela in 1984 to that in 1985?
Make the answer very short. 0.82. What is the ratio of the CO2 emissions (% of total fuel combustion) in Ghana in 1984 to that in 1986?
Your response must be concise. 0.92. What is the ratio of the CO2 emissions (% of total fuel combustion) in Qatar in 1984 to that in 1986?
Provide a succinct answer. 0.65. What is the ratio of the CO2 emissions (% of total fuel combustion) in Tunisia in 1984 to that in 1986?
Your response must be concise. 0.93. What is the ratio of the CO2 emissions (% of total fuel combustion) of Venezuela in 1984 to that in 1986?
Ensure brevity in your answer.  1.03. What is the ratio of the CO2 emissions (% of total fuel combustion) in Ghana in 1984 to that in 1987?
Keep it short and to the point. 0.87. What is the ratio of the CO2 emissions (% of total fuel combustion) in Qatar in 1984 to that in 1987?
Offer a very short reply. 0.27. What is the ratio of the CO2 emissions (% of total fuel combustion) of Tunisia in 1984 to that in 1987?
Your answer should be compact. 0.89. What is the ratio of the CO2 emissions (% of total fuel combustion) in Ghana in 1984 to that in 1988?
Offer a very short reply. 0.92. What is the ratio of the CO2 emissions (% of total fuel combustion) in Qatar in 1984 to that in 1988?
Your answer should be compact. 0.68. What is the ratio of the CO2 emissions (% of total fuel combustion) of Tunisia in 1984 to that in 1988?
Provide a short and direct response. 0.94. What is the ratio of the CO2 emissions (% of total fuel combustion) in Venezuela in 1984 to that in 1988?
Keep it short and to the point. 1.01. What is the ratio of the CO2 emissions (% of total fuel combustion) of Ghana in 1984 to that in 1989?
Ensure brevity in your answer.  0.93. What is the ratio of the CO2 emissions (% of total fuel combustion) of Qatar in 1984 to that in 1989?
Give a very brief answer. 0.16. What is the ratio of the CO2 emissions (% of total fuel combustion) in Venezuela in 1984 to that in 1989?
Ensure brevity in your answer.  1. What is the ratio of the CO2 emissions (% of total fuel combustion) of Ghana in 1984 to that in 1990?
Give a very brief answer. 1.02. What is the ratio of the CO2 emissions (% of total fuel combustion) in Qatar in 1984 to that in 1990?
Your answer should be very brief. 0.39. What is the ratio of the CO2 emissions (% of total fuel combustion) in Tunisia in 1984 to that in 1990?
Make the answer very short. 0.96. What is the ratio of the CO2 emissions (% of total fuel combustion) in Ghana in 1985 to that in 1986?
Ensure brevity in your answer.  1.09. What is the ratio of the CO2 emissions (% of total fuel combustion) of Qatar in 1985 to that in 1986?
Ensure brevity in your answer.  4.08. What is the ratio of the CO2 emissions (% of total fuel combustion) in Tunisia in 1985 to that in 1986?
Make the answer very short. 0.96. What is the ratio of the CO2 emissions (% of total fuel combustion) of Venezuela in 1985 to that in 1986?
Your answer should be compact. 1.26. What is the ratio of the CO2 emissions (% of total fuel combustion) of Ghana in 1985 to that in 1987?
Your answer should be very brief. 1.03. What is the ratio of the CO2 emissions (% of total fuel combustion) in Qatar in 1985 to that in 1987?
Your answer should be very brief. 1.72. What is the ratio of the CO2 emissions (% of total fuel combustion) in Tunisia in 1985 to that in 1987?
Give a very brief answer. 0.92. What is the ratio of the CO2 emissions (% of total fuel combustion) of Venezuela in 1985 to that in 1987?
Your answer should be very brief. 1.21. What is the ratio of the CO2 emissions (% of total fuel combustion) of Ghana in 1985 to that in 1988?
Keep it short and to the point. 1.08. What is the ratio of the CO2 emissions (% of total fuel combustion) in Qatar in 1985 to that in 1988?
Give a very brief answer. 4.27. What is the ratio of the CO2 emissions (% of total fuel combustion) of Tunisia in 1985 to that in 1988?
Make the answer very short. 0.97. What is the ratio of the CO2 emissions (% of total fuel combustion) of Venezuela in 1985 to that in 1988?
Provide a short and direct response. 1.23. What is the ratio of the CO2 emissions (% of total fuel combustion) in Ghana in 1985 to that in 1989?
Provide a short and direct response. 1.09. What is the ratio of the CO2 emissions (% of total fuel combustion) of Qatar in 1985 to that in 1989?
Offer a terse response. 1.03. What is the ratio of the CO2 emissions (% of total fuel combustion) of Venezuela in 1985 to that in 1989?
Make the answer very short. 1.21. What is the ratio of the CO2 emissions (% of total fuel combustion) in Ghana in 1985 to that in 1990?
Ensure brevity in your answer.  1.2. What is the ratio of the CO2 emissions (% of total fuel combustion) in Qatar in 1985 to that in 1990?
Your answer should be very brief. 2.46. What is the ratio of the CO2 emissions (% of total fuel combustion) in Tunisia in 1985 to that in 1990?
Your response must be concise. 0.99. What is the ratio of the CO2 emissions (% of total fuel combustion) of Venezuela in 1985 to that in 1990?
Ensure brevity in your answer.  1.27. What is the ratio of the CO2 emissions (% of total fuel combustion) of Ghana in 1986 to that in 1987?
Offer a terse response. 0.95. What is the ratio of the CO2 emissions (% of total fuel combustion) in Qatar in 1986 to that in 1987?
Keep it short and to the point. 0.42. What is the ratio of the CO2 emissions (% of total fuel combustion) in Tunisia in 1986 to that in 1987?
Your answer should be very brief. 0.96. What is the ratio of the CO2 emissions (% of total fuel combustion) of Venezuela in 1986 to that in 1987?
Your answer should be very brief. 0.97. What is the ratio of the CO2 emissions (% of total fuel combustion) of Qatar in 1986 to that in 1988?
Give a very brief answer. 1.05. What is the ratio of the CO2 emissions (% of total fuel combustion) in Tunisia in 1986 to that in 1988?
Offer a very short reply. 1.01. What is the ratio of the CO2 emissions (% of total fuel combustion) of Venezuela in 1986 to that in 1988?
Ensure brevity in your answer.  0.98. What is the ratio of the CO2 emissions (% of total fuel combustion) of Qatar in 1986 to that in 1989?
Provide a short and direct response. 0.25. What is the ratio of the CO2 emissions (% of total fuel combustion) in Tunisia in 1986 to that in 1989?
Make the answer very short. 1.04. What is the ratio of the CO2 emissions (% of total fuel combustion) of Venezuela in 1986 to that in 1989?
Your answer should be very brief. 0.97. What is the ratio of the CO2 emissions (% of total fuel combustion) of Ghana in 1986 to that in 1990?
Your answer should be compact. 1.1. What is the ratio of the CO2 emissions (% of total fuel combustion) in Qatar in 1986 to that in 1990?
Make the answer very short. 0.6. What is the ratio of the CO2 emissions (% of total fuel combustion) of Tunisia in 1986 to that in 1990?
Give a very brief answer. 1.03. What is the ratio of the CO2 emissions (% of total fuel combustion) in Venezuela in 1986 to that in 1990?
Make the answer very short. 1.01. What is the ratio of the CO2 emissions (% of total fuel combustion) in Ghana in 1987 to that in 1988?
Offer a terse response. 1.05. What is the ratio of the CO2 emissions (% of total fuel combustion) in Qatar in 1987 to that in 1988?
Offer a terse response. 2.48. What is the ratio of the CO2 emissions (% of total fuel combustion) in Tunisia in 1987 to that in 1988?
Your response must be concise. 1.06. What is the ratio of the CO2 emissions (% of total fuel combustion) of Venezuela in 1987 to that in 1988?
Your answer should be very brief. 1.01. What is the ratio of the CO2 emissions (% of total fuel combustion) of Ghana in 1987 to that in 1989?
Ensure brevity in your answer.  1.06. What is the ratio of the CO2 emissions (% of total fuel combustion) in Qatar in 1987 to that in 1989?
Provide a succinct answer. 0.6. What is the ratio of the CO2 emissions (% of total fuel combustion) of Tunisia in 1987 to that in 1989?
Your response must be concise. 1.09. What is the ratio of the CO2 emissions (% of total fuel combustion) in Venezuela in 1987 to that in 1989?
Your response must be concise. 1. What is the ratio of the CO2 emissions (% of total fuel combustion) of Ghana in 1987 to that in 1990?
Offer a very short reply. 1.16. What is the ratio of the CO2 emissions (% of total fuel combustion) in Qatar in 1987 to that in 1990?
Offer a terse response. 1.43. What is the ratio of the CO2 emissions (% of total fuel combustion) of Tunisia in 1987 to that in 1990?
Offer a very short reply. 1.08. What is the ratio of the CO2 emissions (% of total fuel combustion) in Venezuela in 1987 to that in 1990?
Provide a succinct answer. 1.04. What is the ratio of the CO2 emissions (% of total fuel combustion) in Ghana in 1988 to that in 1989?
Your response must be concise. 1.01. What is the ratio of the CO2 emissions (% of total fuel combustion) in Qatar in 1988 to that in 1989?
Provide a short and direct response. 0.24. What is the ratio of the CO2 emissions (% of total fuel combustion) of Tunisia in 1988 to that in 1989?
Provide a succinct answer. 1.03. What is the ratio of the CO2 emissions (% of total fuel combustion) of Venezuela in 1988 to that in 1989?
Give a very brief answer. 0.98. What is the ratio of the CO2 emissions (% of total fuel combustion) in Ghana in 1988 to that in 1990?
Your answer should be very brief. 1.11. What is the ratio of the CO2 emissions (% of total fuel combustion) in Qatar in 1988 to that in 1990?
Make the answer very short. 0.58. What is the ratio of the CO2 emissions (% of total fuel combustion) of Tunisia in 1988 to that in 1990?
Make the answer very short. 1.02. What is the ratio of the CO2 emissions (% of total fuel combustion) of Venezuela in 1988 to that in 1990?
Provide a succinct answer. 1.03. What is the ratio of the CO2 emissions (% of total fuel combustion) in Ghana in 1989 to that in 1990?
Make the answer very short. 1.1. What is the ratio of the CO2 emissions (% of total fuel combustion) in Qatar in 1989 to that in 1990?
Make the answer very short. 2.38. What is the ratio of the CO2 emissions (% of total fuel combustion) in Venezuela in 1989 to that in 1990?
Make the answer very short. 1.04. What is the difference between the highest and the second highest CO2 emissions (% of total fuel combustion) in Ghana?
Your response must be concise. 0.51. What is the difference between the highest and the second highest CO2 emissions (% of total fuel combustion) in Qatar?
Provide a short and direct response. 0.05. What is the difference between the highest and the second highest CO2 emissions (% of total fuel combustion) in Tunisia?
Your answer should be very brief. 0.64. What is the difference between the highest and the second highest CO2 emissions (% of total fuel combustion) in Venezuela?
Keep it short and to the point. 1.12. What is the difference between the highest and the lowest CO2 emissions (% of total fuel combustion) in Ghana?
Your response must be concise. 3.11. What is the difference between the highest and the lowest CO2 emissions (% of total fuel combustion) of Qatar?
Give a very brief answer. 1.3. What is the difference between the highest and the lowest CO2 emissions (% of total fuel combustion) of Tunisia?
Give a very brief answer. 1.58. What is the difference between the highest and the lowest CO2 emissions (% of total fuel combustion) of Venezuela?
Provide a succinct answer. 1.34. 